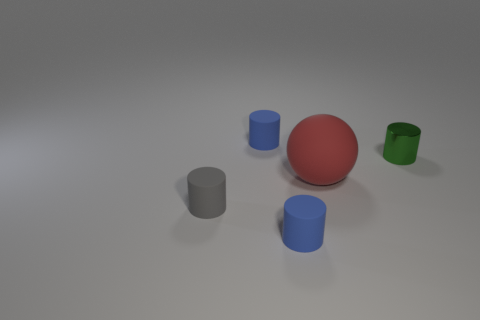Add 3 tiny green shiny cylinders. How many objects exist? 8 Subtract all balls. How many objects are left? 4 Add 5 gray matte objects. How many gray matte objects are left? 6 Add 5 brown rubber things. How many brown rubber things exist? 5 Subtract 0 gray balls. How many objects are left? 5 Subtract all large gray cylinders. Subtract all metal cylinders. How many objects are left? 4 